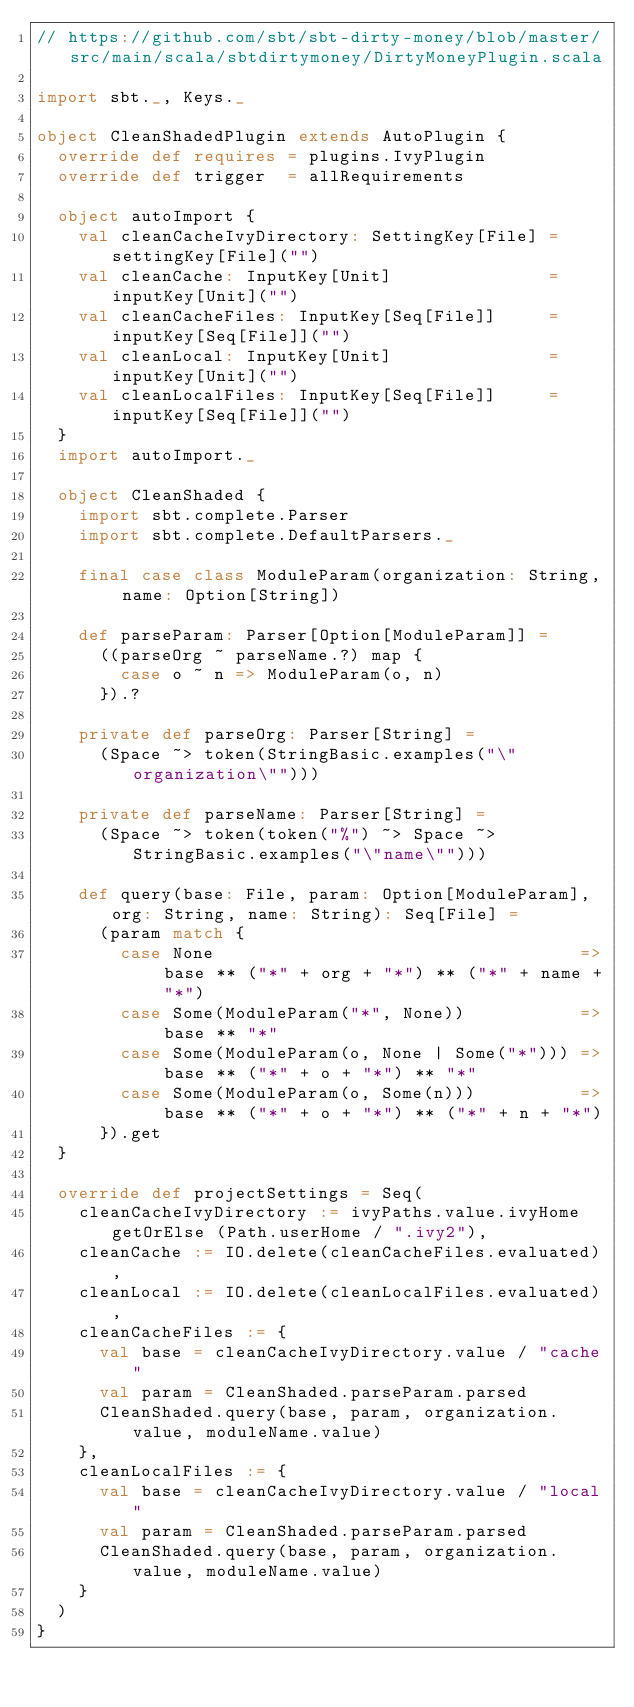<code> <loc_0><loc_0><loc_500><loc_500><_Scala_>// https://github.com/sbt/sbt-dirty-money/blob/master/src/main/scala/sbtdirtymoney/DirtyMoneyPlugin.scala

import sbt._, Keys._

object CleanShadedPlugin extends AutoPlugin {
  override def requires = plugins.IvyPlugin
  override def trigger  = allRequirements

  object autoImport {
    val cleanCacheIvyDirectory: SettingKey[File] = settingKey[File]("")
    val cleanCache: InputKey[Unit]               = inputKey[Unit]("")
    val cleanCacheFiles: InputKey[Seq[File]]     = inputKey[Seq[File]]("")
    val cleanLocal: InputKey[Unit]               = inputKey[Unit]("")
    val cleanLocalFiles: InputKey[Seq[File]]     = inputKey[Seq[File]]("")
  }
  import autoImport._

  object CleanShaded {
    import sbt.complete.Parser
    import sbt.complete.DefaultParsers._

    final case class ModuleParam(organization: String, name: Option[String])

    def parseParam: Parser[Option[ModuleParam]] =
      ((parseOrg ~ parseName.?) map {
        case o ~ n => ModuleParam(o, n)
      }).?

    private def parseOrg: Parser[String] =
      (Space ~> token(StringBasic.examples("\"organization\"")))

    private def parseName: Parser[String] =
      (Space ~> token(token("%") ~> Space ~> StringBasic.examples("\"name\"")))

    def query(base: File, param: Option[ModuleParam], org: String, name: String): Seq[File] =
      (param match {
        case None                                   => base ** ("*" + org + "*") ** ("*" + name + "*")
        case Some(ModuleParam("*", None))           => base ** "*"
        case Some(ModuleParam(o, None | Some("*"))) => base ** ("*" + o + "*") ** "*"
        case Some(ModuleParam(o, Some(n)))          => base ** ("*" + o + "*") ** ("*" + n + "*")
      }).get
  }

  override def projectSettings = Seq(
    cleanCacheIvyDirectory := ivyPaths.value.ivyHome getOrElse (Path.userHome / ".ivy2"),
    cleanCache := IO.delete(cleanCacheFiles.evaluated),
    cleanLocal := IO.delete(cleanLocalFiles.evaluated),
    cleanCacheFiles := {
      val base = cleanCacheIvyDirectory.value / "cache"
      val param = CleanShaded.parseParam.parsed
      CleanShaded.query(base, param, organization.value, moduleName.value)
    },
    cleanLocalFiles := {
      val base = cleanCacheIvyDirectory.value / "local"
      val param = CleanShaded.parseParam.parsed
      CleanShaded.query(base, param, organization.value, moduleName.value)
    }
  )
}
</code> 